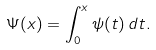Convert formula to latex. <formula><loc_0><loc_0><loc_500><loc_500>\Psi ( x ) = \int _ { 0 } ^ { x } \psi ( t ) \, d t .</formula> 